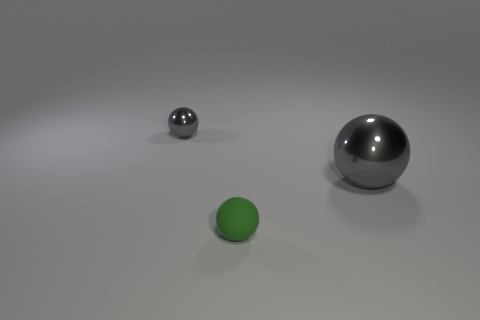Do the spheres seem to be affected by any light source in the scene? Yes, the spheres are displaying highlights and shadows that suggest the presence of a light source off-camera, possibly above them, giving a sense of depth and dimension to the objects. 